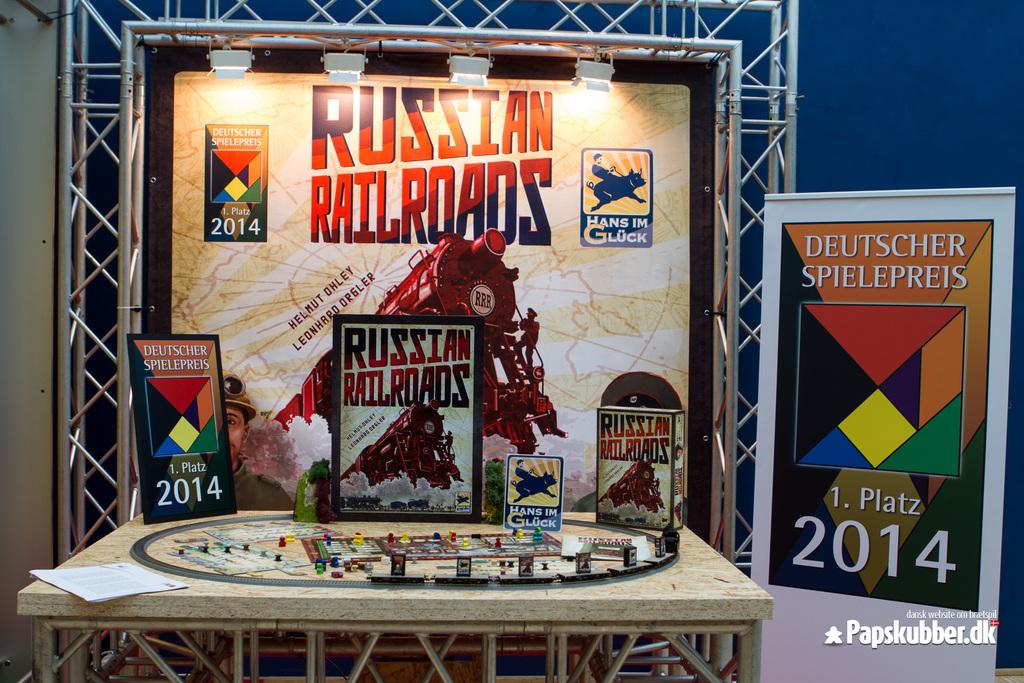What is the title of the poster?
Offer a very short reply. Russian railroads. What year is this?
Keep it short and to the point. 2014. 